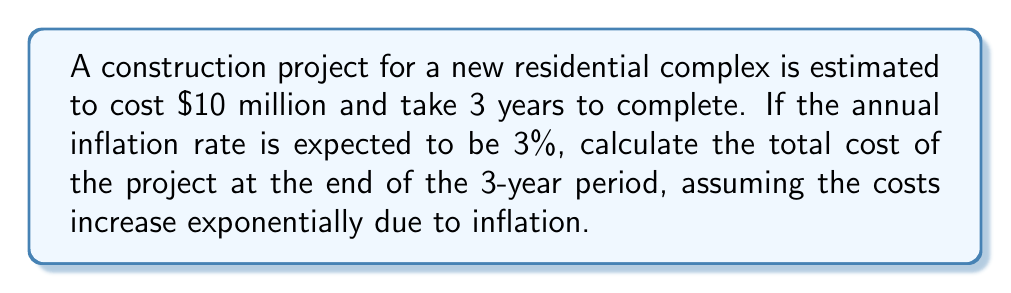Give your solution to this math problem. To solve this problem, we'll use the exponential growth formula:

$$A = P(1 + r)^t$$

Where:
$A$ = Final amount
$P$ = Initial principal (original cost)
$r$ = Annual inflation rate (as a decimal)
$t$ = Time in years

Given:
$P = \$10,000,000$
$r = 0.03$ (3% expressed as a decimal)
$t = 3$ years

Step 1: Substitute the values into the formula.
$$A = 10,000,000(1 + 0.03)^3$$

Step 2: Simplify the expression inside the parentheses.
$$A = 10,000,000(1.03)^3$$

Step 3: Calculate the exponent.
$$A = 10,000,000(1.092727)$$

Step 4: Multiply to get the final amount.
$$A = 10,927,270$$

Therefore, the total cost of the project after 3 years, accounting for inflation, will be $10,927,270.
Answer: $10,927,270 